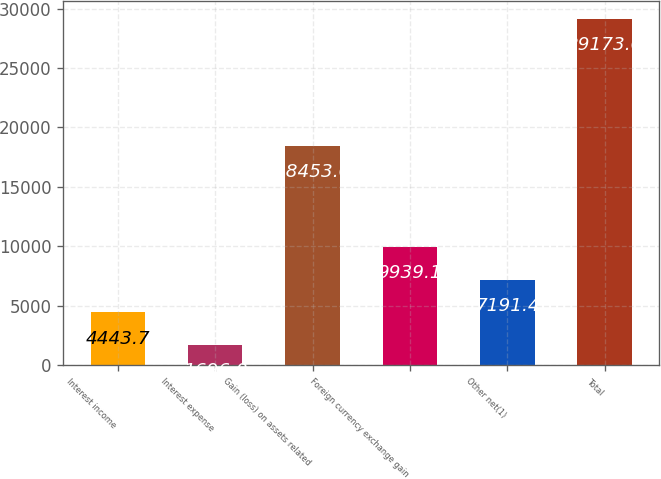Convert chart to OTSL. <chart><loc_0><loc_0><loc_500><loc_500><bar_chart><fcel>Interest income<fcel>Interest expense<fcel>Gain (loss) on assets related<fcel>Foreign currency exchange gain<fcel>Other net(1)<fcel>Total<nl><fcel>4443.7<fcel>1696<fcel>18453<fcel>9939.1<fcel>7191.4<fcel>29173<nl></chart> 